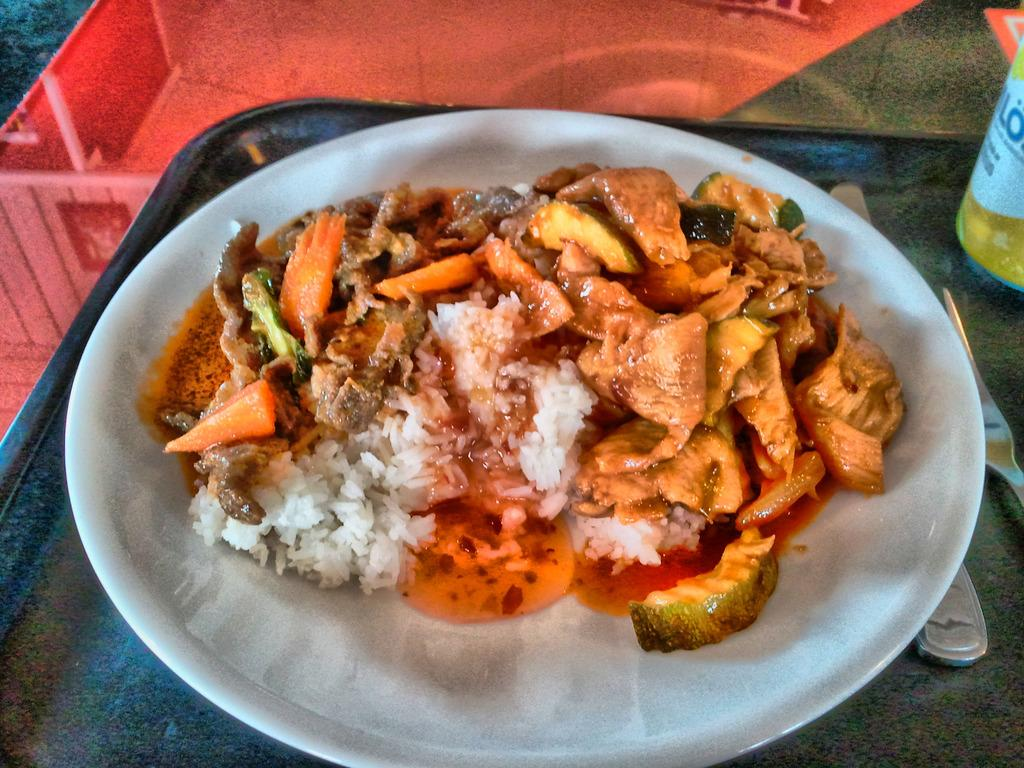What color is the plate in the image? The plate in the image is white. What is on the plate? The plate contains food. How is the plate positioned in the image? The plate is placed in a tray. What utensils are present in the image? There is a fork and a spoon in the image. What else can be seen in the image besides the plate and utensils? There is a bottle in the image. What is the size of the wrist in the image? There is no wrist present in the image. What type of liquid is in the bottle in the image? The image does not provide information about the contents of the bottle, so we cannot determine if it contains a liquid or not. 